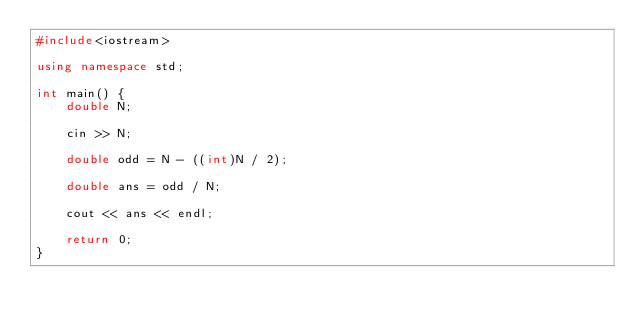<code> <loc_0><loc_0><loc_500><loc_500><_C++_>#include<iostream>

using namespace std;

int main() {
    double N;

    cin >> N;

    double odd = N - ((int)N / 2);

    double ans = odd / N;

    cout << ans << endl;

    return 0;
}
</code> 